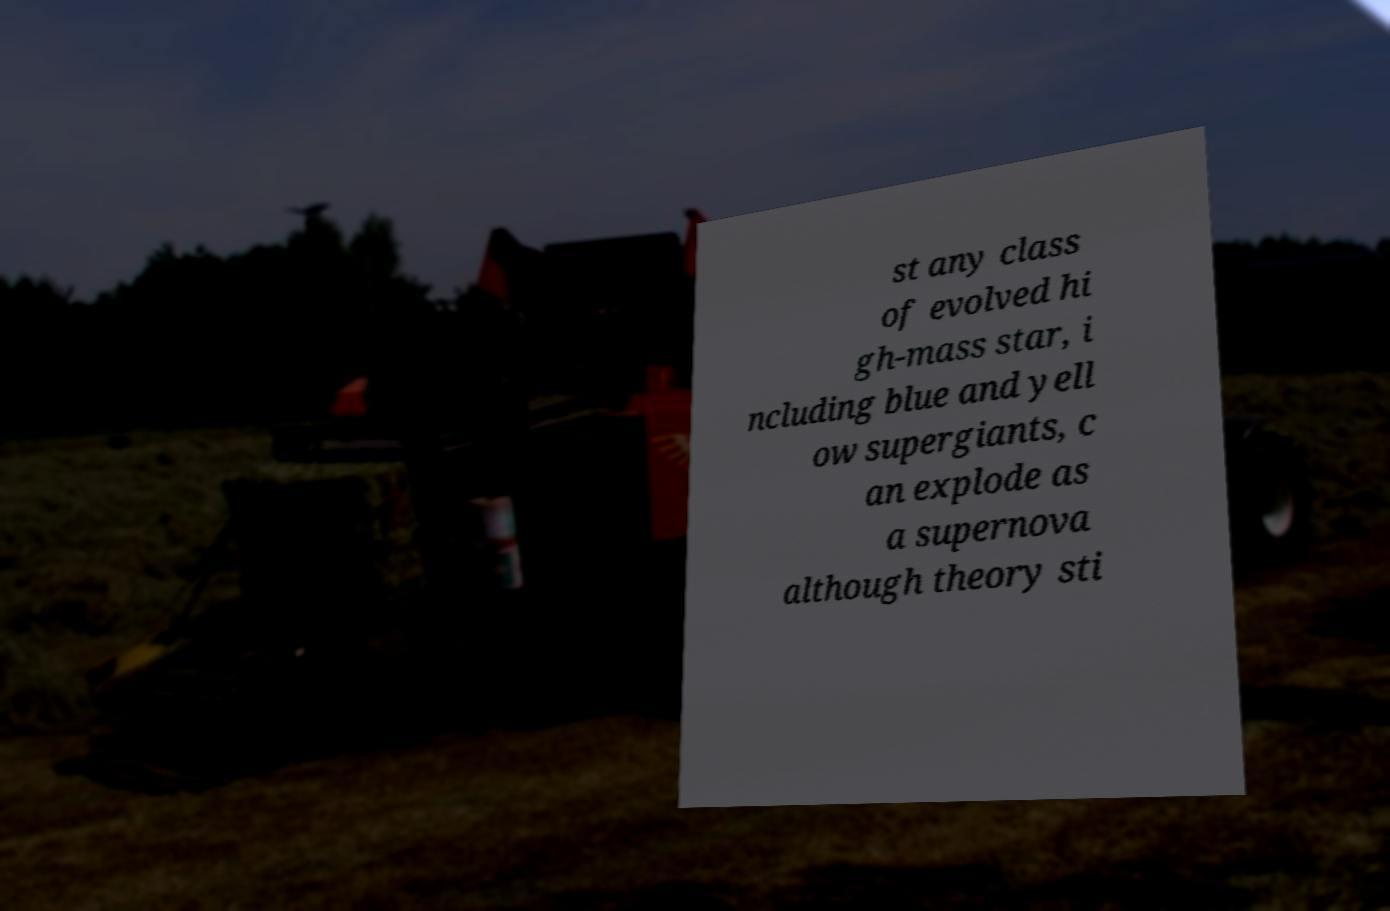Can you accurately transcribe the text from the provided image for me? st any class of evolved hi gh-mass star, i ncluding blue and yell ow supergiants, c an explode as a supernova although theory sti 